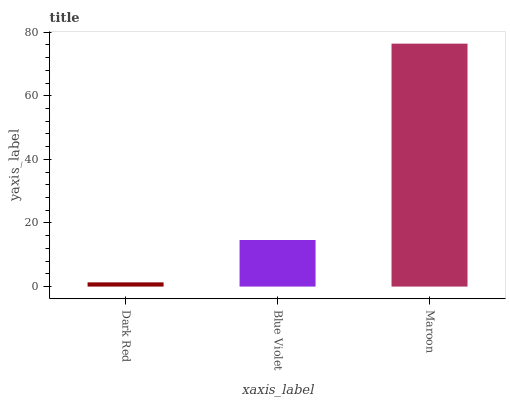Is Dark Red the minimum?
Answer yes or no. Yes. Is Maroon the maximum?
Answer yes or no. Yes. Is Blue Violet the minimum?
Answer yes or no. No. Is Blue Violet the maximum?
Answer yes or no. No. Is Blue Violet greater than Dark Red?
Answer yes or no. Yes. Is Dark Red less than Blue Violet?
Answer yes or no. Yes. Is Dark Red greater than Blue Violet?
Answer yes or no. No. Is Blue Violet less than Dark Red?
Answer yes or no. No. Is Blue Violet the high median?
Answer yes or no. Yes. Is Blue Violet the low median?
Answer yes or no. Yes. Is Maroon the high median?
Answer yes or no. No. Is Dark Red the low median?
Answer yes or no. No. 